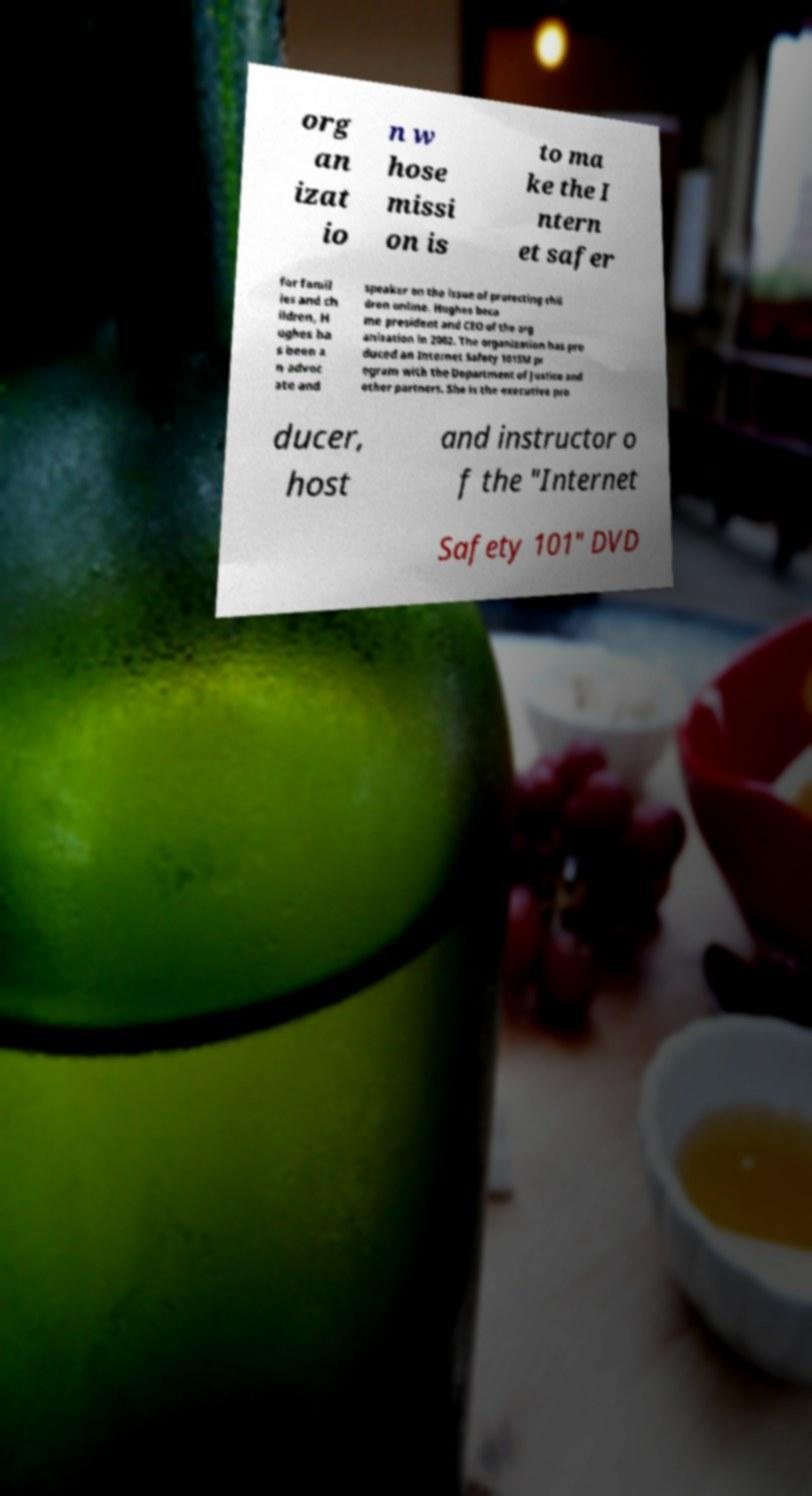Could you extract and type out the text from this image? org an izat io n w hose missi on is to ma ke the I ntern et safer for famil ies and ch ildren, H ughes ha s been a n advoc ate and speaker on the issue of protecting chil dren online. Hughes beca me president and CEO of the org anization in 2002. The organization has pro duced an Internet Safety 101SM pr ogram with the Department of Justice and other partners. She is the executive pro ducer, host and instructor o f the "Internet Safety 101" DVD 